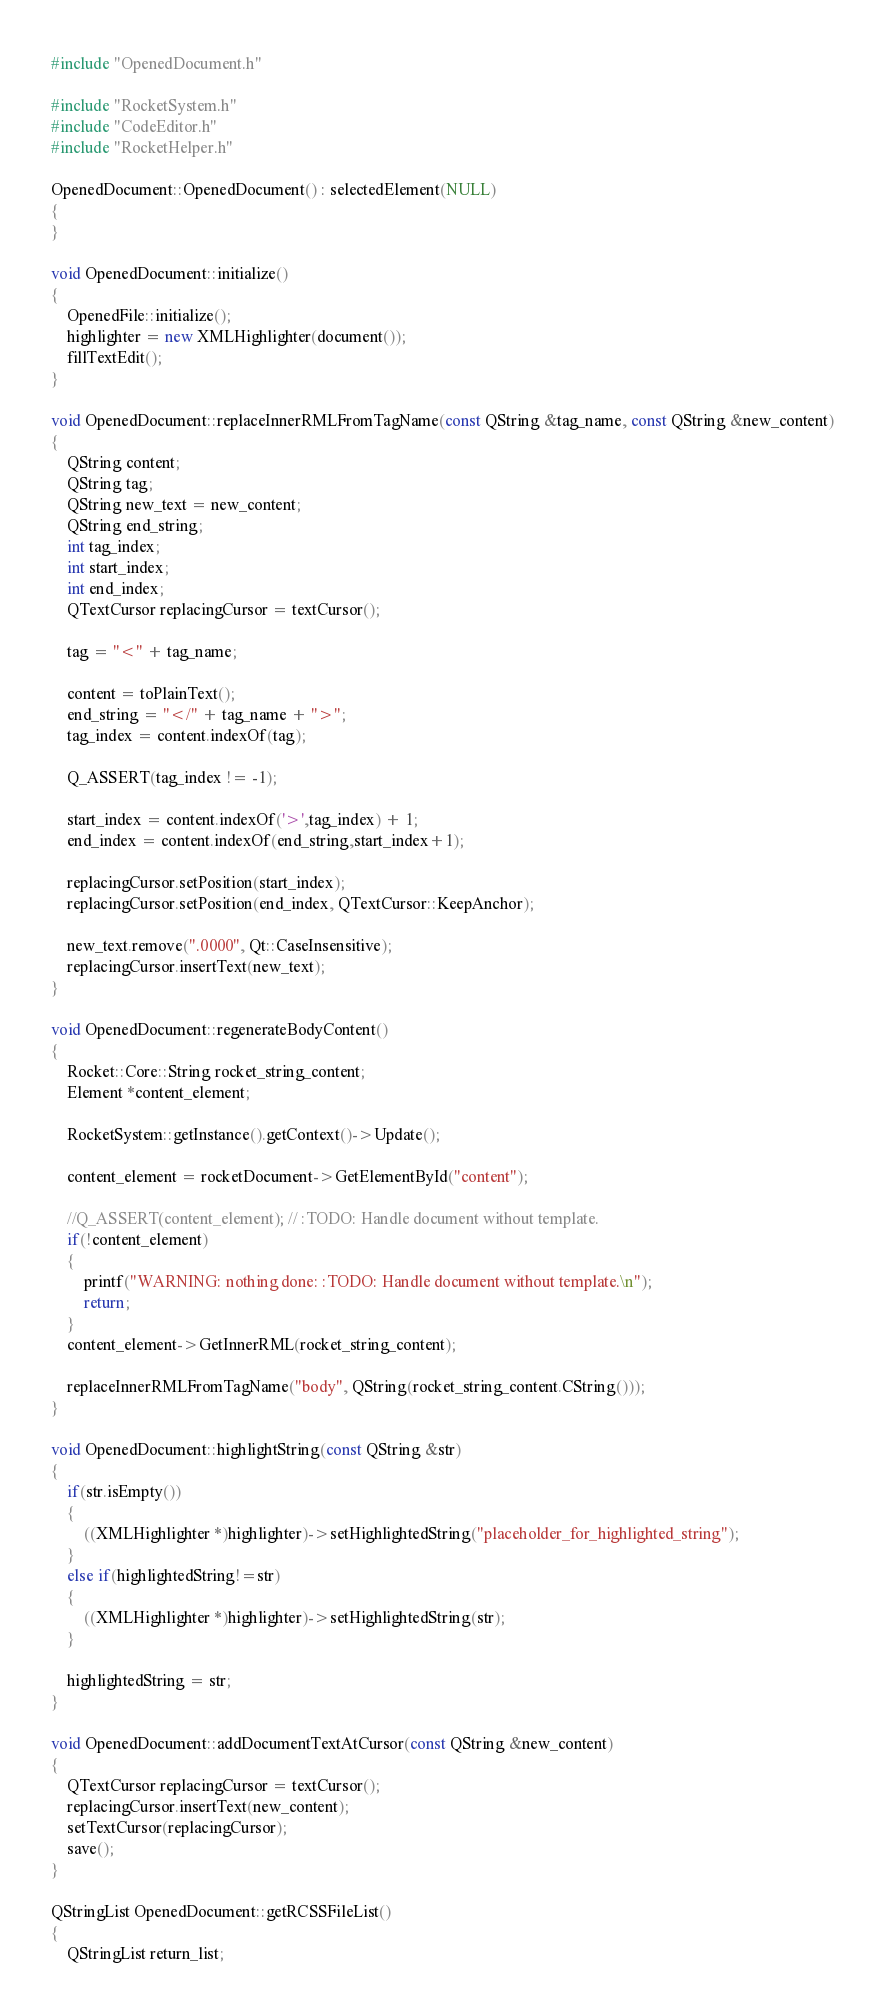Convert code to text. <code><loc_0><loc_0><loc_500><loc_500><_C++_>#include "OpenedDocument.h"

#include "RocketSystem.h"
#include "CodeEditor.h"
#include "RocketHelper.h"

OpenedDocument::OpenedDocument() : selectedElement(NULL)
{
}

void OpenedDocument::initialize()
{
    OpenedFile::initialize();
    highlighter = new XMLHighlighter(document());
    fillTextEdit();
}

void OpenedDocument::replaceInnerRMLFromTagName(const QString &tag_name, const QString &new_content)
{
    QString content;
    QString tag;
    QString new_text = new_content;
    QString end_string;
    int tag_index;
    int start_index;
    int end_index;
    QTextCursor replacingCursor = textCursor();

    tag = "<" + tag_name;

    content = toPlainText();
    end_string = "</" + tag_name + ">";
    tag_index = content.indexOf(tag);

    Q_ASSERT(tag_index != -1);

    start_index = content.indexOf('>',tag_index) + 1;
    end_index = content.indexOf(end_string,start_index+1);

    replacingCursor.setPosition(start_index);
    replacingCursor.setPosition(end_index, QTextCursor::KeepAnchor);

    new_text.remove(".0000", Qt::CaseInsensitive);
    replacingCursor.insertText(new_text);
}

void OpenedDocument::regenerateBodyContent()
{
    Rocket::Core::String rocket_string_content;
    Element *content_element;

    RocketSystem::getInstance().getContext()->Update();

    content_element = rocketDocument->GetElementById("content");

    //Q_ASSERT(content_element); // :TODO: Handle document without template.
    if(!content_element)
    {
        printf("WARNING: nothing done: :TODO: Handle document without template.\n");
        return;
    }
    content_element->GetInnerRML(rocket_string_content);

    replaceInnerRMLFromTagName("body", QString(rocket_string_content.CString()));
}

void OpenedDocument::highlightString(const QString &str)
{
    if(str.isEmpty())
    {
        ((XMLHighlighter *)highlighter)->setHighlightedString("placeholder_for_highlighted_string");
    }
    else if(highlightedString!=str)
    {
        ((XMLHighlighter *)highlighter)->setHighlightedString(str);
    }

    highlightedString = str;
}

void OpenedDocument::addDocumentTextAtCursor(const QString &new_content)
{
    QTextCursor replacingCursor = textCursor();
    replacingCursor.insertText(new_content);
    setTextCursor(replacingCursor);
    save();
}

QStringList OpenedDocument::getRCSSFileList()
{
    QStringList return_list;
</code> 